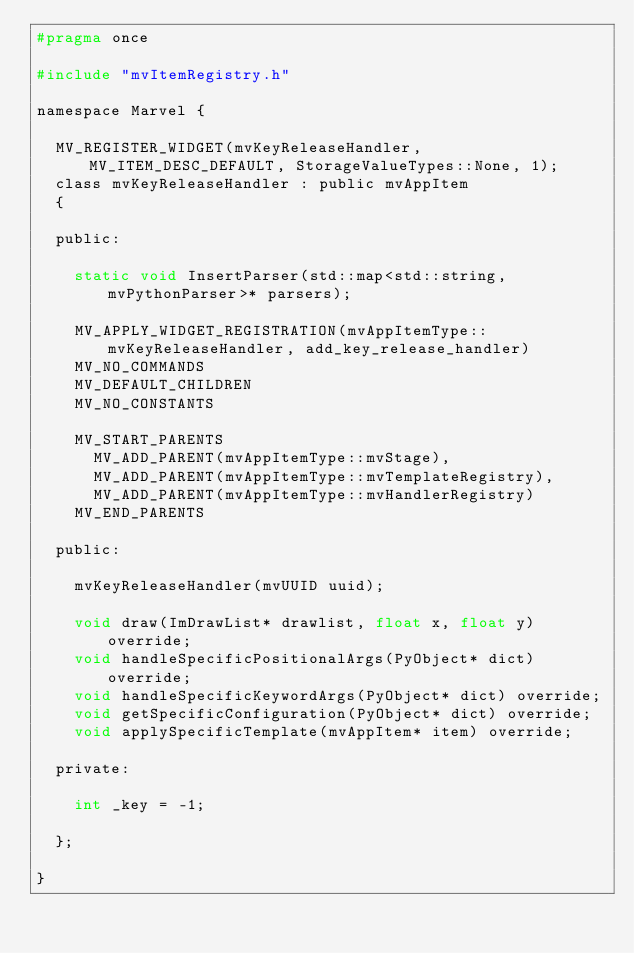<code> <loc_0><loc_0><loc_500><loc_500><_C_>#pragma once

#include "mvItemRegistry.h"

namespace Marvel {

	MV_REGISTER_WIDGET(mvKeyReleaseHandler, MV_ITEM_DESC_DEFAULT, StorageValueTypes::None, 1);
	class mvKeyReleaseHandler : public mvAppItem
	{

	public:

		static void InsertParser(std::map<std::string, mvPythonParser>* parsers);

		MV_APPLY_WIDGET_REGISTRATION(mvAppItemType::mvKeyReleaseHandler, add_key_release_handler)
		MV_NO_COMMANDS
		MV_DEFAULT_CHILDREN
		MV_NO_CONSTANTS

		MV_START_PARENTS
			MV_ADD_PARENT(mvAppItemType::mvStage),
			MV_ADD_PARENT(mvAppItemType::mvTemplateRegistry),
			MV_ADD_PARENT(mvAppItemType::mvHandlerRegistry)
		MV_END_PARENTS

	public:

		mvKeyReleaseHandler(mvUUID uuid);

		void draw(ImDrawList* drawlist, float x, float y) override;
		void handleSpecificPositionalArgs(PyObject* dict) override;
		void handleSpecificKeywordArgs(PyObject* dict) override;
		void getSpecificConfiguration(PyObject* dict) override;
		void applySpecificTemplate(mvAppItem* item) override;

	private:

		int _key = -1;

	};

}
</code> 